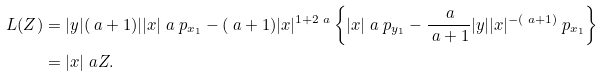Convert formula to latex. <formula><loc_0><loc_0><loc_500><loc_500>L ( Z ) & = | y | ( \ a + 1 ) | | x | ^ { \ } a \ p _ { x _ { 1 } } - ( \ a + 1 ) | x | ^ { 1 + 2 \ a } \left \{ | x | ^ { \ } a \ p _ { y _ { 1 } } - \frac { \ a } { \ a + 1 } | y | | x | ^ { - ( \ a + 1 ) } \ p _ { x _ { 1 } } \right \} \\ & = | x | ^ { \ } a Z .</formula> 